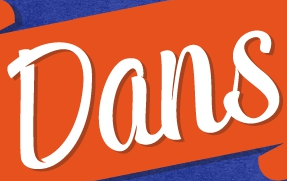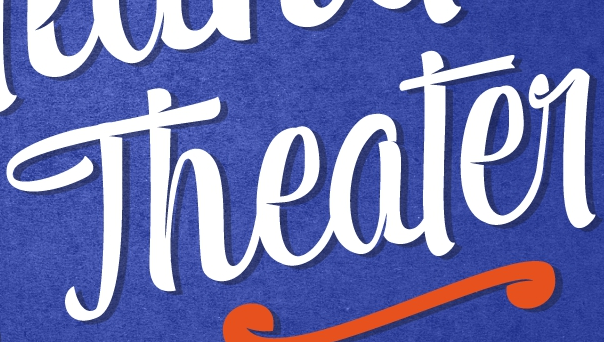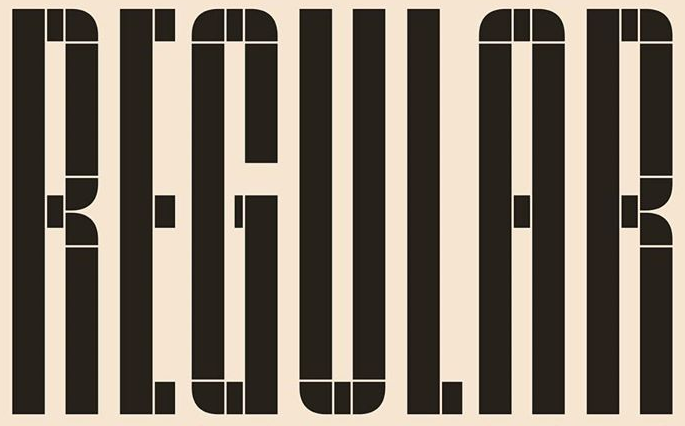Read the text from these images in sequence, separated by a semicolon. Dans; Theater; REGULAR 